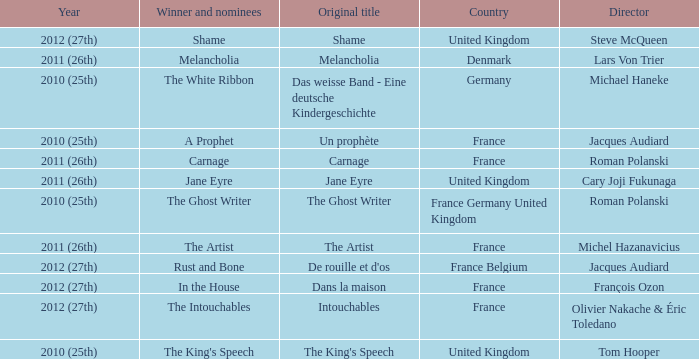Who was the winner and nominees for the movie directed by cary joji fukunaga? Jane Eyre. 